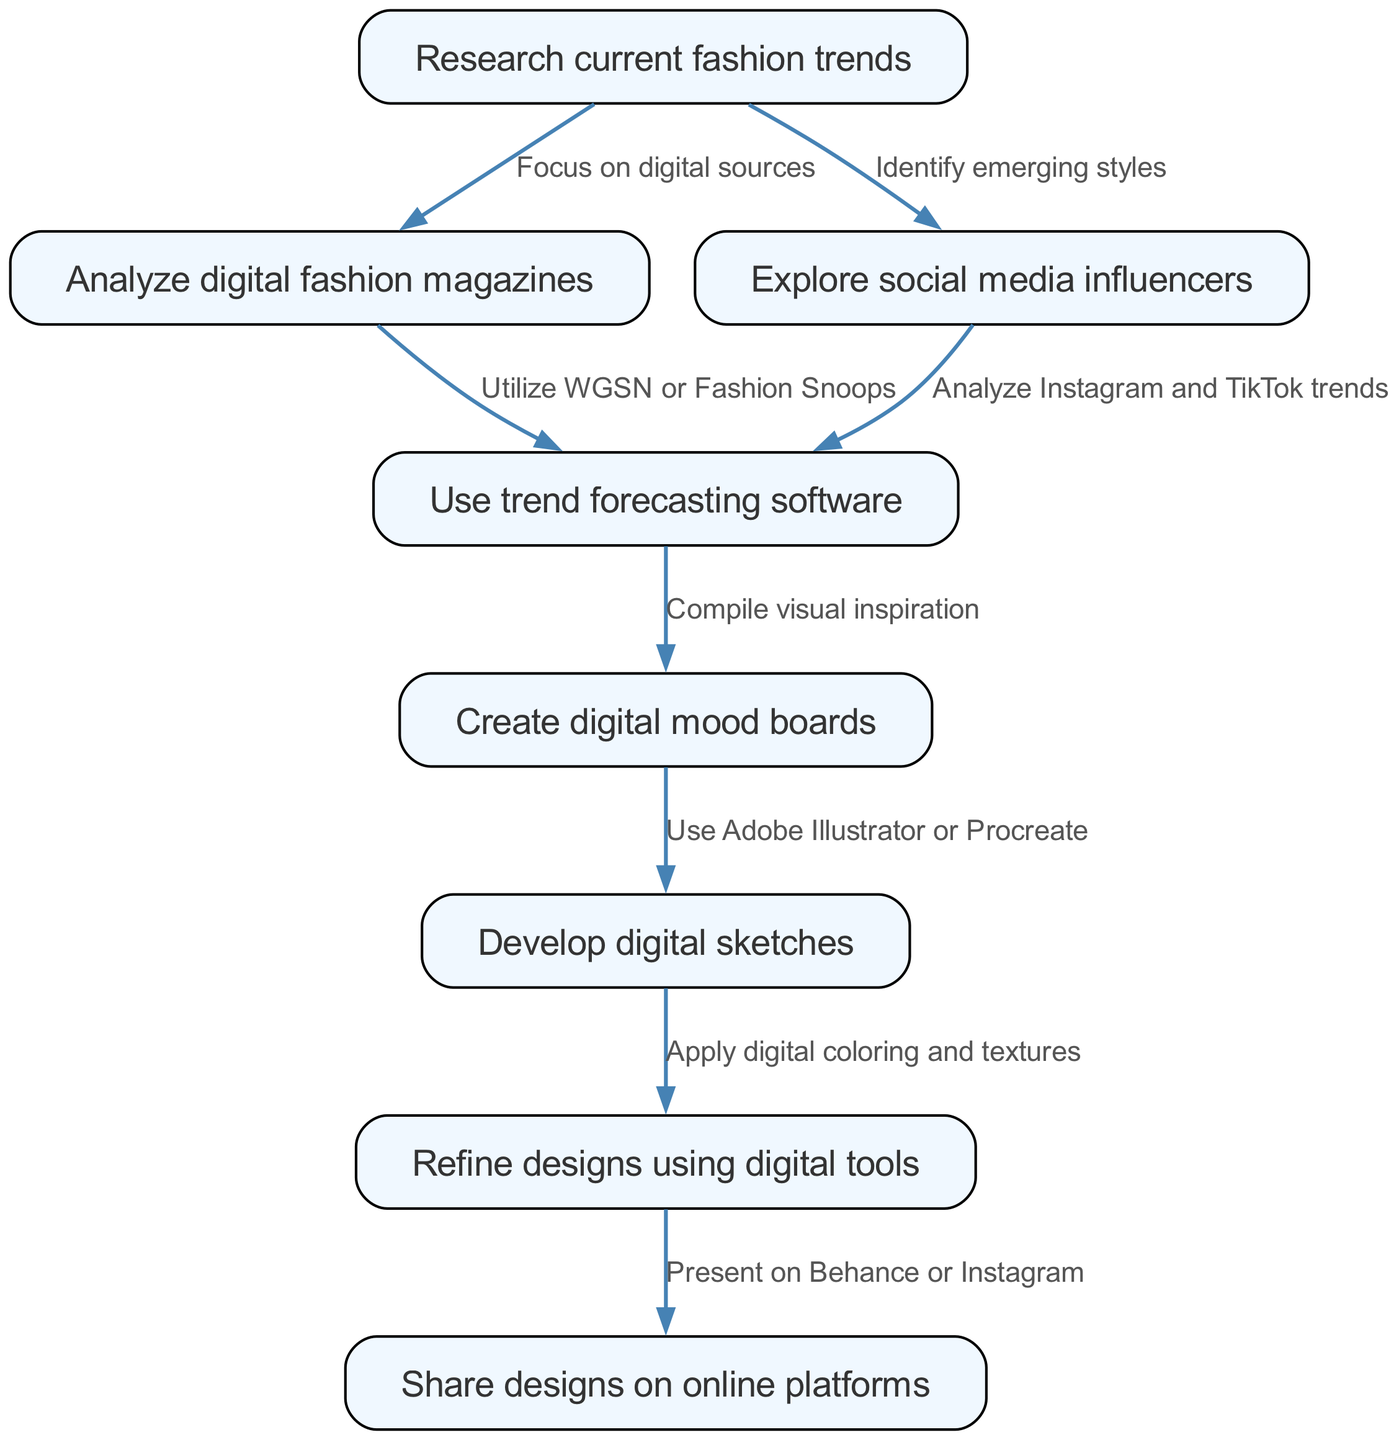What is the first step in the fashion trend forecasting process? The first step, as shown in the diagram, is "Research current fashion trends." This is indicated as the topmost node in the pathway, representing the starting point.
Answer: Research current fashion trends How many nodes are present in the diagram? The diagram contains eight nodes, which represent different steps in the clinical pathway of fashion trend forecasting. This can be counted by reviewing each unique node listed.
Answer: 8 What relationship was established between "Analyze digital fashion magazines" and "Use trend forecasting software"? The relationship is established through the edge labeled "Utilize WGSN or Fashion Snoops." This indicates that analyzing digital magazines leads to the use of trend forecasting software and shows a direct connection between these two steps.
Answer: Utilize WGSN or Fashion Snoops Which digital tools are mentioned for creating digital sketches? The tools mentioned for creating digital sketches are "Adobe Illustrator or Procreate." This information is connected through the edge leading from "Create digital mood boards" to "Develop digital sketches."
Answer: Adobe Illustrator or Procreate What are the last two steps in the fashion trend forecasting clinical pathway? The last two steps are "Refine designs using digital tools" and "Share designs on online platforms." These nodes are the final steps in the sequence of the workflow, showing what follows after developing digital sketches.
Answer: Refine designs using digital tools, Share designs on online platforms If you analyze social media influencers, what tool do you utilize next? After analyzing social media influencers, you would utilize "trend forecasting software," as indicated by the edge between these two steps, showing a direct progression based on the pathway.
Answer: trend forecasting software What is the link between "Create digital mood boards" and "Develop digital sketches"? The link is represented by the edge labeled "Use Adobe Illustrator or Procreate," indicating that creating mood boards is directly connected to the development of sketches using these tools.
Answer: Use Adobe Illustrator or Procreate Which platform is used for sharing designs? The platform used for sharing designs is "Behance or Instagram," as shown in the last node of the diagram, detailing where designs can be presented online.
Answer: Behance or Instagram 